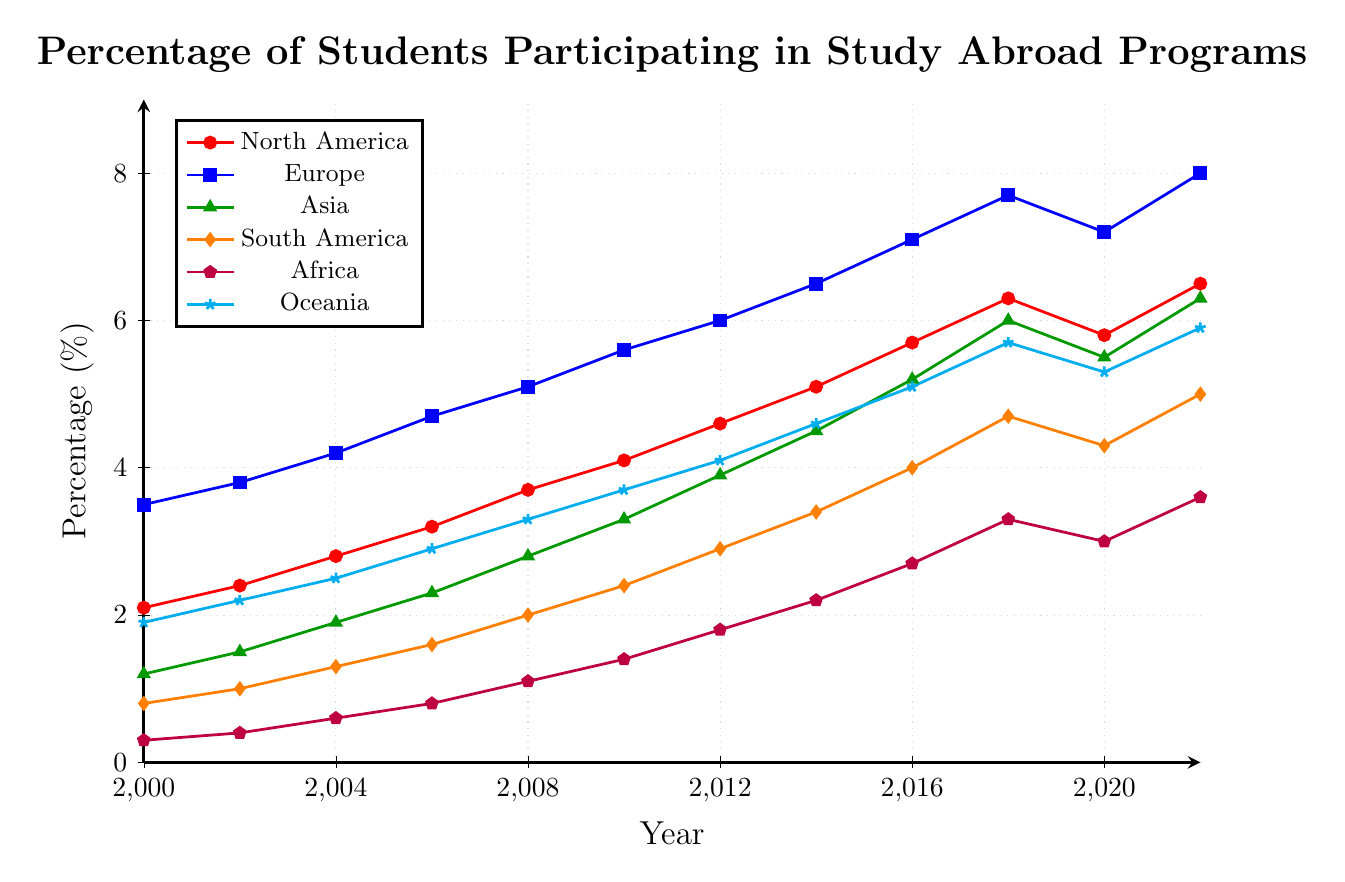Which continent had the highest percentage of students participating in study abroad programs in 2018? In 2018, Europe had the highest percentage of students participating in study abroad programs, which is represented by the blue line reaching 7.7%.
Answer: Europe By how many percentage points did the participation rate for Africa increase from 2000 to 2022? The participation rate for Africa in 2000 was 0.3%, and in 2022 it was 3.6%. The increase is calculated as 3.6% - 0.3% = 3.3 percentage points.
Answer: 3.3 Which continent experienced the largest percentage growth between 2000 and 2022? By comparing the percentages between 2000 and 2022 for each continent: North America (6.5 - 2.1 = 4.4), Europe (8.0 - 3.5 = 4.5), Asia (6.3 - 1.2 = 5.1), South America (5.0 - 0.8 = 4.2), Africa (3.6 - 0.3 = 3.3), and Oceania (5.9 - 1.9 = 4.0). Asia experienced the largest growth of 5.1 percentage points.
Answer: Asia In which year did North America see its highest percentage of students participating? North America's highest percentage was in 2022, with a value of 6.5%.
Answer: 2022 From 2000 to 2022, did any continent show a decrease in the percentage of students participating at any point, and if so, which one(s)? Upon examining the values over the years, only North America and Europe show a percentage decrease between 2018 and 2020: North America (6.3% to 5.8%) and Europe (7.7% to 7.2%).
Answer: North America, Europe What was the overall trend in study abroad participation percentages for Oceania from 2000 to 2022? The trend for Oceania shows a steady increase over the years from 1.9% in 2000 to 5.9% in 2022.
Answer: Increasing Compare the participation rates in 2010 between North America and South America. Which continent had a higher percentage and by how much? In 2010, North America had a participation rate of 4.1% while South America had 2.4%. The difference is 4.1% - 2.4% = 1.7%.
Answer: North America by 1.7% What is the average participation percentage for Asia from 2000 to 2008? The percentages for Asia from 2000 to 2008 are: 1.2%, 1.5%, 1.9%, 2.3%, and 2.8%. The sum is 1.2 + 1.5 + 1.9 + 2.3 + 2.8 = 9.7. There are 5 data points, so the average is 9.7 / 5 = 1.94%.
Answer: 1.94 If you combine the 2022 percentages of North America and Africa, what percentage do you get? In 2022, North America's percentage is 6.5%, and Africa's percentage is 3.6%. The combined percentage is 6.5% + 3.6% = 10.1%.
Answer: 10.1 